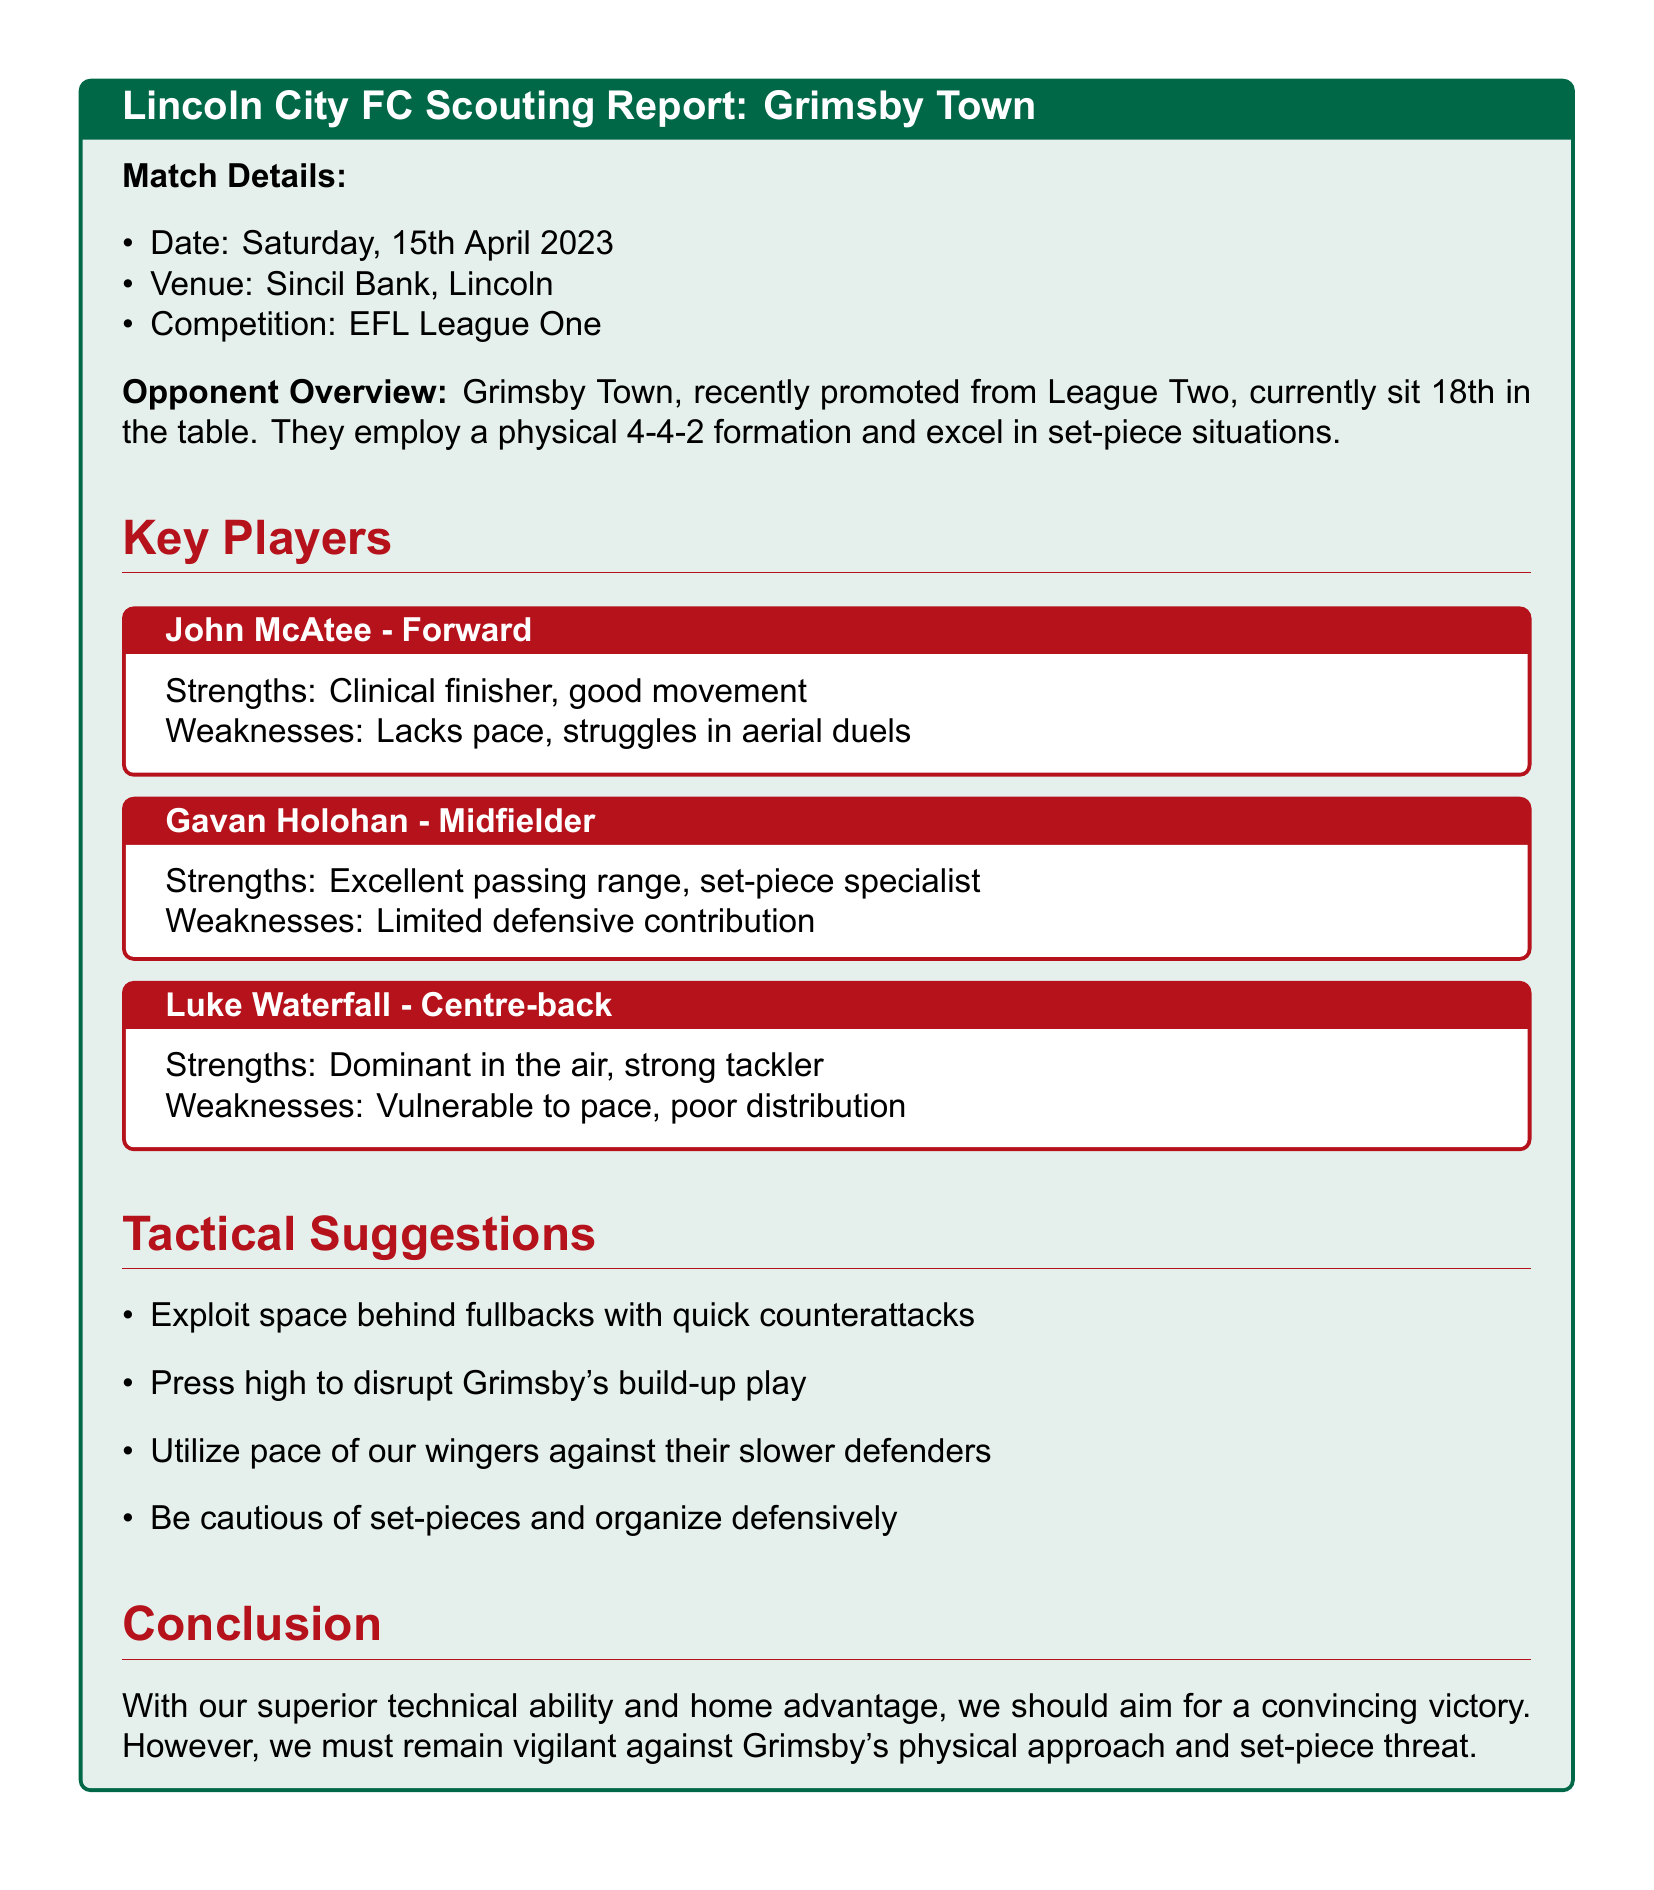What is the date of the match? The date of the match is specified in the document under "Match Details."
Answer: Saturday, 15th April 2023 What is Grimsby Town's current league position? The document states that Grimsby Town currently sits 18th in the table.
Answer: 18th Which formation does Grimsby Town employ? The formation used by Grimsby Town is mentioned in the "Opponent Overview."
Answer: 4-4-2 Who is considered a set-piece specialist? The report identifies a specific player noted for set-pieces.
Answer: Gavan Holohan What is a suggested tactical approach against Grimsby Town? The document outlines tactical suggestions, one of which involves exploiting space.
Answer: Exploit space behind fullbacks What is a weakness of John McAtee? The document lists specific weaknesses for each key player; one of McAtee's weaknesses is mentioned.
Answer: Lacks pace Which player is dominant in the air? The document highlights players and their strengths; one is specifically noted for aerial dominance.
Answer: Luke Waterfall What advantage does Lincoln City have in the match? The conclusion emphasizes a specific advantage for Lincoln City going into the match.
Answer: Home advantage 